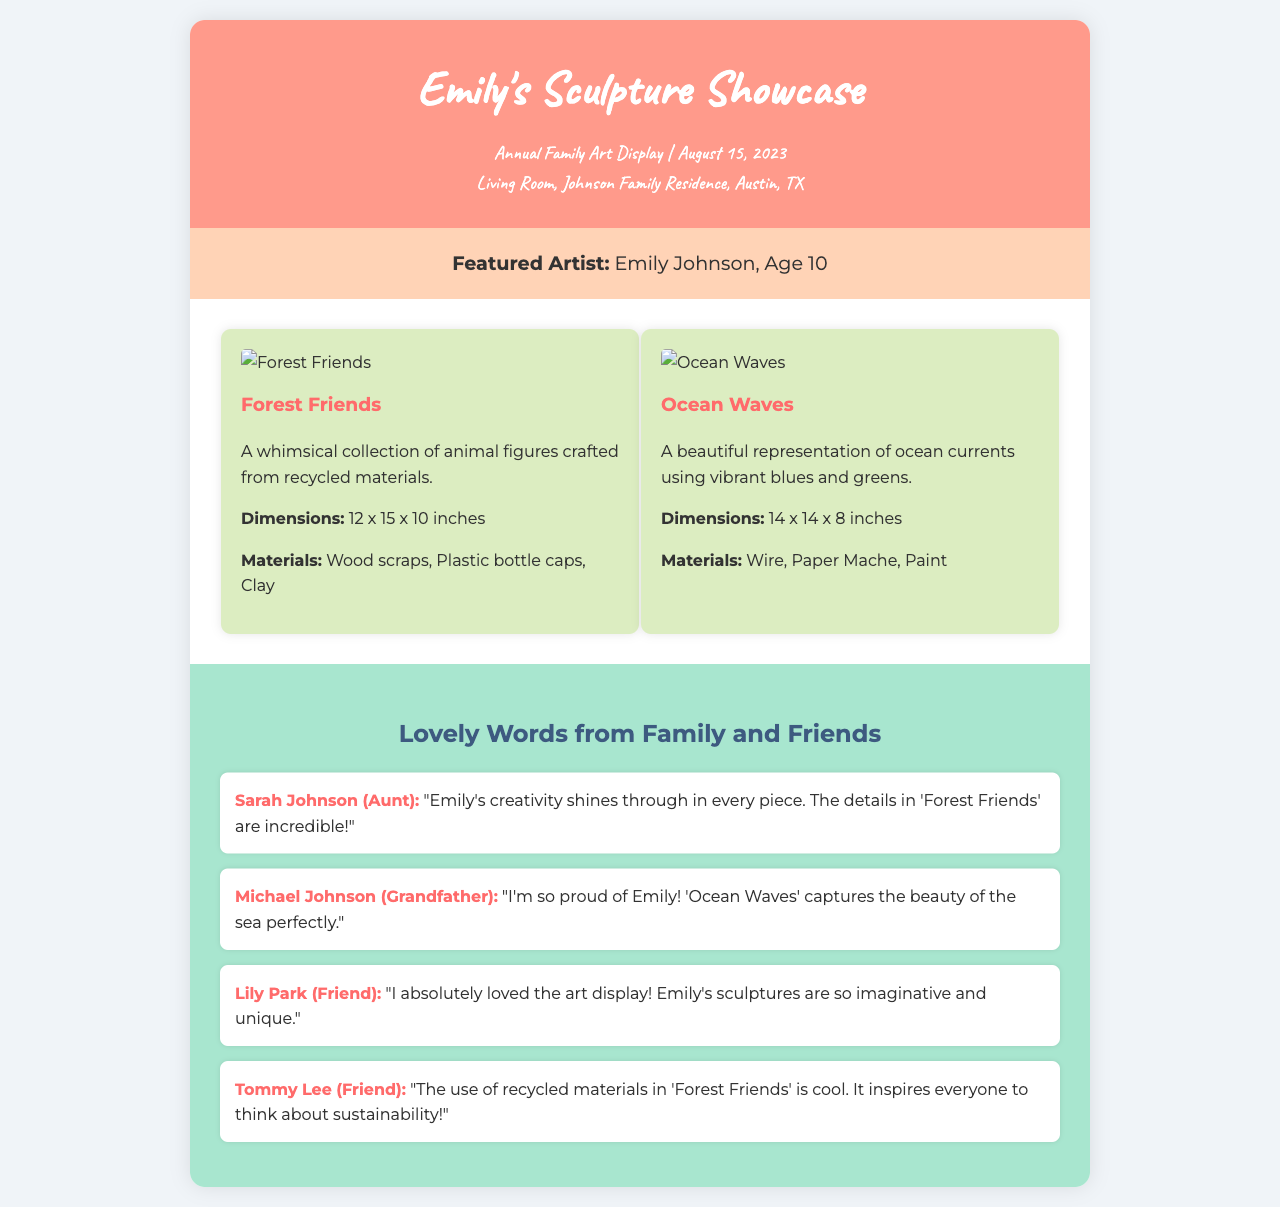What is the name of the featured artist? The featured artist is mentioned in the artist info section of the document as Emily Johnson.
Answer: Emily Johnson What is the age of the featured artist? The document states that Emily Johnson is 10 years old.
Answer: 10 What date was the annual family art display held? The event details section indicates that the display occurred on August 15, 2023.
Answer: August 15, 2023 What is the title of the first sculpture showcased? The first sculpture is identified as "Forest Friends" in the sculptures section.
Answer: Forest Friends How many sculptures are displayed in total? The sculptures section lists two sculptures being showcased.
Answer: 2 What materials were used for "Ocean Waves"? The materials used are listed in the sculpture details as Wire, Paper Mache, Paint.
Answer: Wire, Paper Mache, Paint Who left feedback praising the creativity in "Forest Friends"? The feedback section credits Sarah Johnson, the aunt, for her praise of Emily's creativity.
Answer: Sarah Johnson What was Tommy Lee’s comment about "Forest Friends"? The feedback from Tommy Lee mentions the use of recycled materials inspiring thoughts about sustainability.
Answer: Inspires everyone to think about sustainability What is the theme of "Ocean Waves"? The document describes "Ocean Waves" as a representation of ocean currents using vibrant colors.
Answer: Ocean currents In which room was the art display held? The event details specifically mention the Living Room as the display's location.
Answer: Living Room 